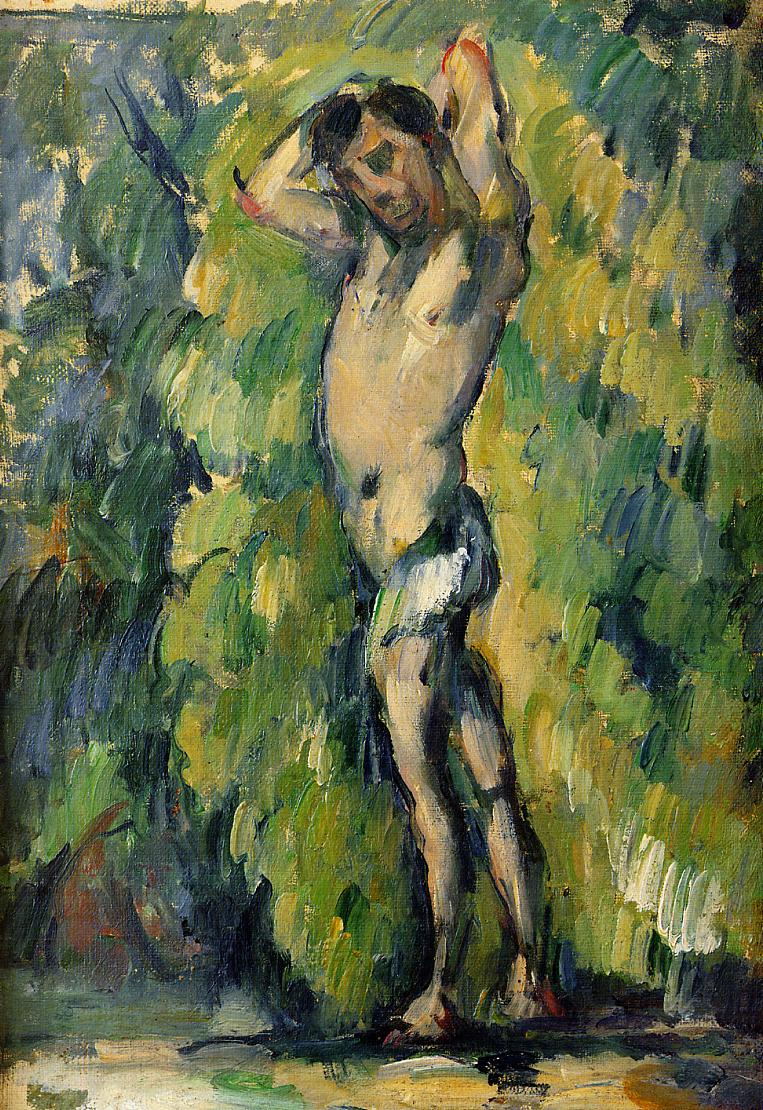What do you think is going on in this snapshot? The image presents an impressionist painting depicting a nude woman in a natural setting. The figure is centrally positioned, with arms raised and encircled by a lush environment of dense, green foliage. This art piece, characterized by its vibrant yet harmonious use of greens and yellows against splashes of white and blue, is a classic example of impressionism, aimed at capturing moments of light and color. These elements not only highlight the artist's technique but also enhance the ethereal and tranquil mood of the scene. Such works often aim to evoke a sensory response and may reflect themes of natural beauty and human vulnerability. 